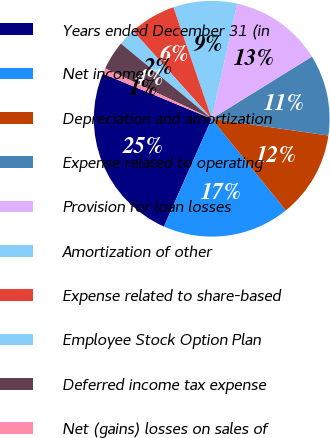Convert chart to OTSL. <chart><loc_0><loc_0><loc_500><loc_500><pie_chart><fcel>Years ended December 31 (in<fcel>Net income<fcel>Depreciation and amortization<fcel>Expense related to operating<fcel>Provision for loan losses<fcel>Amortization of other<fcel>Expense related to share-based<fcel>Employee Stock Option Plan<fcel>Deferred income tax expense<fcel>Net (gains) losses on sales of<nl><fcel>24.6%<fcel>17.46%<fcel>11.9%<fcel>11.11%<fcel>12.7%<fcel>8.73%<fcel>6.35%<fcel>2.38%<fcel>3.97%<fcel>0.79%<nl></chart> 